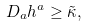<formula> <loc_0><loc_0><loc_500><loc_500>D _ { a } h ^ { a } \geq \tilde { \kappa } ,</formula> 